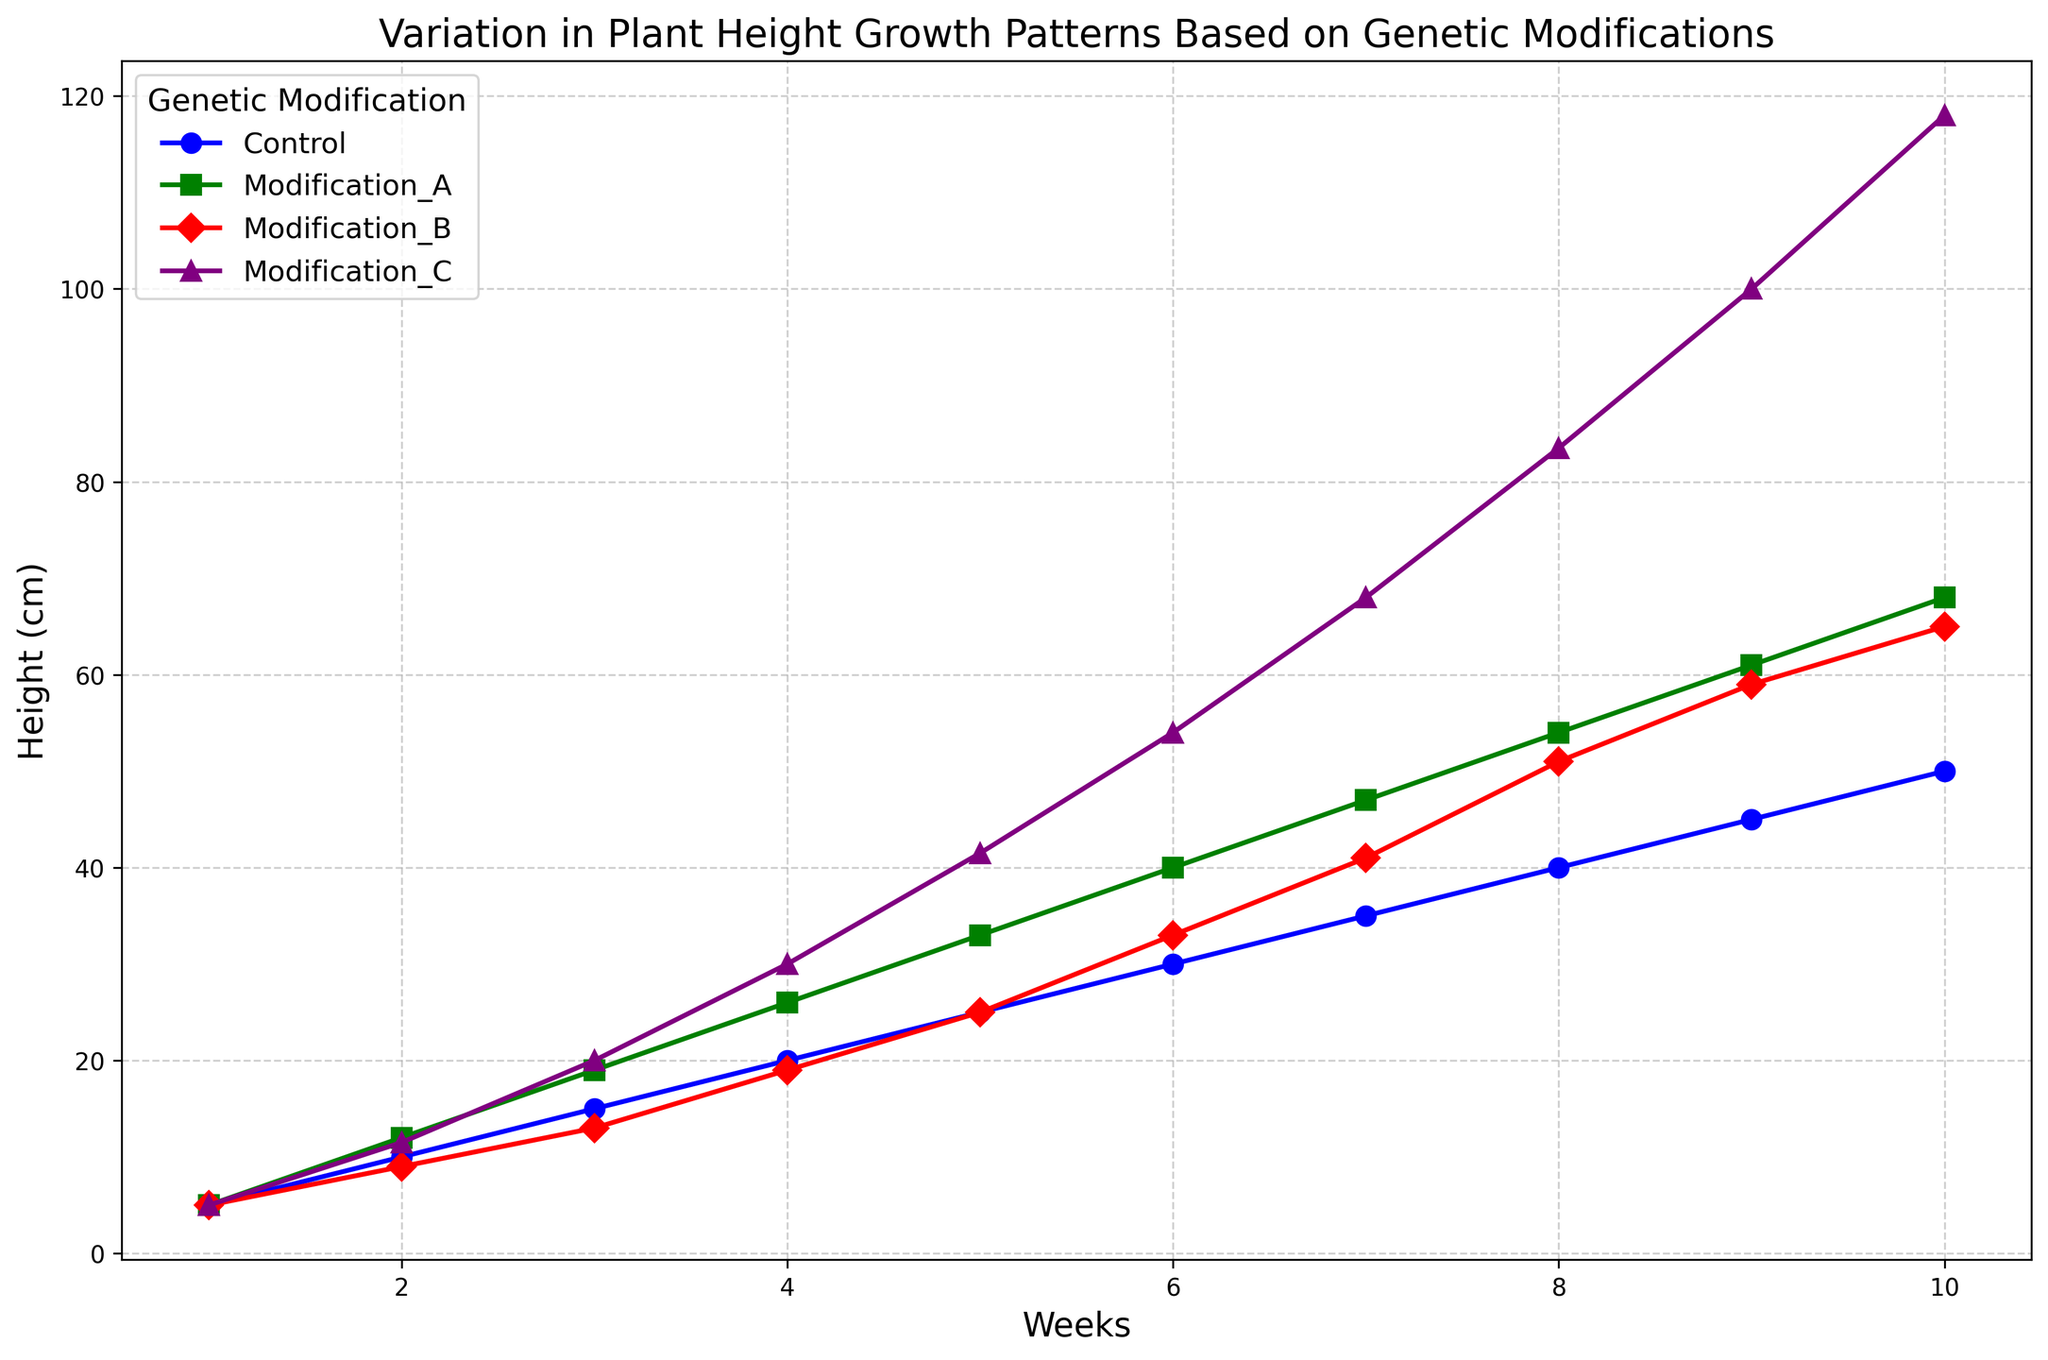What is the final height of plants under Modification C at week 10? Identify the data point where the genetic modification is Modification C and the week is 10. The height is shown as 118 cm.
Answer: 118 cm Which genetic modification leads to the tallest plants at week 5? Compare the heights of all genetic modifications at week 5: Control (25 cm), Modification A (33 cm), Modification B (25 cm), and Modification C (41.5 cm). Modification C has the tallest plants.
Answer: Modification C Between which weeks does the height of plants under the Control group first reach above 30 cm? Look at the data points for the Control group and find when the height exceeds 30 cm: at week 6 the height is exactly 30 cm, and it reaches 35 cm at week 7.
Answer: Between week 6 and week 7 By how much does the height of plants under Modification B change from week 3 to week 4? Calculate the difference between the heights at week 4 (19 cm) and week 3 (13 cm) for Modification B. The change is 19 - 13 = 6 cm.
Answer: 6 cm What is the average height of plants under the Control group at week 4 and week 8? Find the height of the Control group at week 4 (20 cm) and week 8 (40 cm). Calculate the average: (20 + 40) / 2 = 30 cm.
Answer: 30 cm Which genetic modification shows the steepest increase in plant height from week 6 to week 7? Compare the changes from week 6 to week 7 for each modification: Control (30 to 35 cm, +5 cm), Modification A (40 to 47 cm, +7 cm), Modification B (33 to 41 cm, +8 cm), and Modification C (54 to 68 cm, +14 cm). Modification C has the steepest increase.
Answer: Modification C What is the color used to represent plants under the Control group in the plot? Identify the color of the line representing the Control group in the plot legend. The Control group is depicted in blue.
Answer: Blue Which genetic modification shows the highest average growth rate over the 10 weeks? Calculate the average growth rate: Control (50 cm / 10 weeks = 5 cm/week), Modification A (68 cm / 10 weeks = 6.8 cm/week), Modification B (65 cm / 10 weeks = 6.5 cm/week), and Modification C (118 cm / 10 weeks = 11.8 cm/week). Modification C has the highest average growth rate.
Answer: Modification C 